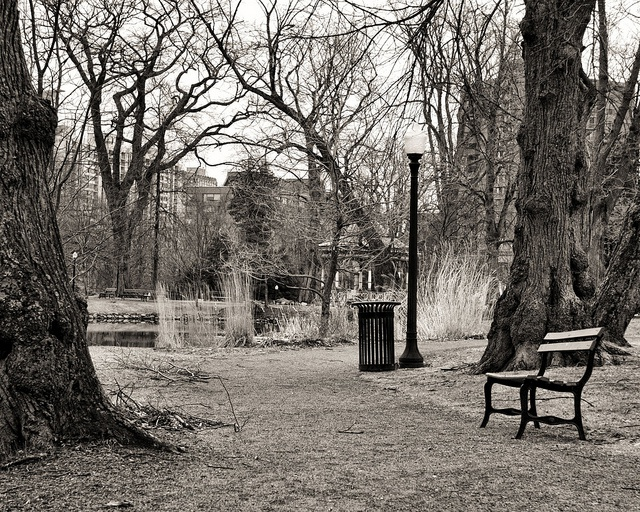Describe the objects in this image and their specific colors. I can see a bench in black, darkgray, gray, and lightgray tones in this image. 